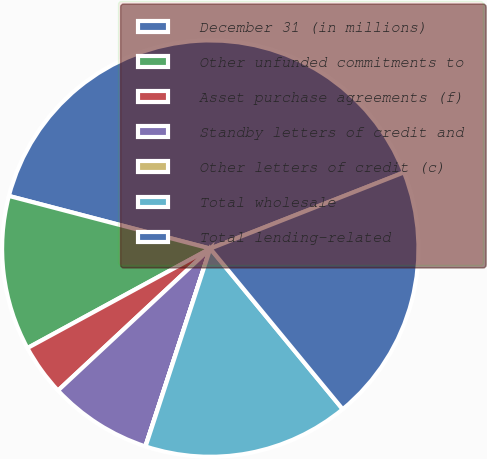Convert chart to OTSL. <chart><loc_0><loc_0><loc_500><loc_500><pie_chart><fcel>December 31 (in millions)<fcel>Other unfunded commitments to<fcel>Asset purchase agreements (f)<fcel>Standby letters of credit and<fcel>Other letters of credit (c)<fcel>Total wholesale<fcel>Total lending-related<nl><fcel>39.96%<fcel>12.0%<fcel>4.01%<fcel>8.01%<fcel>0.02%<fcel>16.0%<fcel>19.99%<nl></chart> 